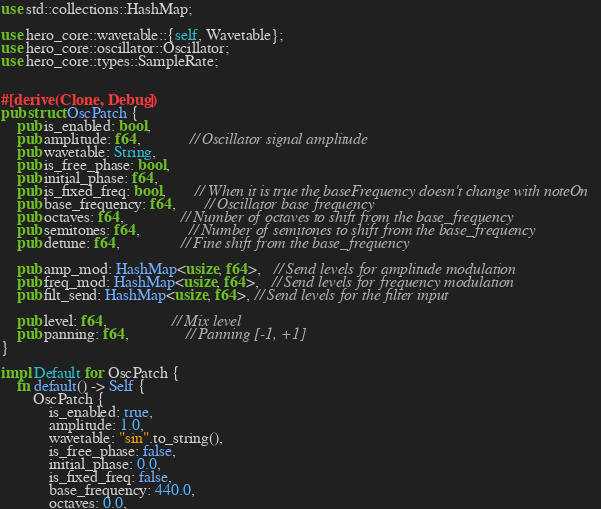<code> <loc_0><loc_0><loc_500><loc_500><_Rust_>use std::collections::HashMap;

use hero_core::wavetable::{self, Wavetable};
use hero_core::oscillator::Oscillator;
use hero_core::types::SampleRate;


#[derive(Clone, Debug)]
pub struct OscPatch {
    pub is_enabled: bool,
    pub amplitude: f64,            // Oscillator signal amplitude
    pub wavetable: String,
    pub is_free_phase: bool,
    pub initial_phase: f64,
    pub is_fixed_freq: bool,       // When it is true the baseFrequency doesn't change with noteOn
    pub base_frequency: f64,       // Oscillator base frequency
    pub octaves: f64,              // Number of octaves to shift from the base_frequency
    pub semitones: f64,            // Number of semitones to shift from the base_frequency
    pub detune: f64,               // Fine shift from the base_frequency

    pub amp_mod: HashMap<usize, f64>,   // Send levels for amplitude modulation
    pub freq_mod: HashMap<usize, f64>,   // Send levels for frequency modulation
    pub filt_send: HashMap<usize, f64>, // Send levels for the filter input

    pub level: f64,                // Mix level
    pub panning: f64,              // Panning [-1, +1]
}

impl Default for OscPatch {
    fn default() -> Self {
        OscPatch {
            is_enabled: true,
            amplitude: 1.0,
            wavetable: "sin".to_string(),
            is_free_phase: false,
            initial_phase: 0.0,
            is_fixed_freq: false,
            base_frequency: 440.0,
            octaves: 0.0,</code> 